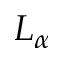Convert formula to latex. <formula><loc_0><loc_0><loc_500><loc_500>L _ { \alpha }</formula> 